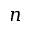Convert formula to latex. <formula><loc_0><loc_0><loc_500><loc_500>n</formula> 